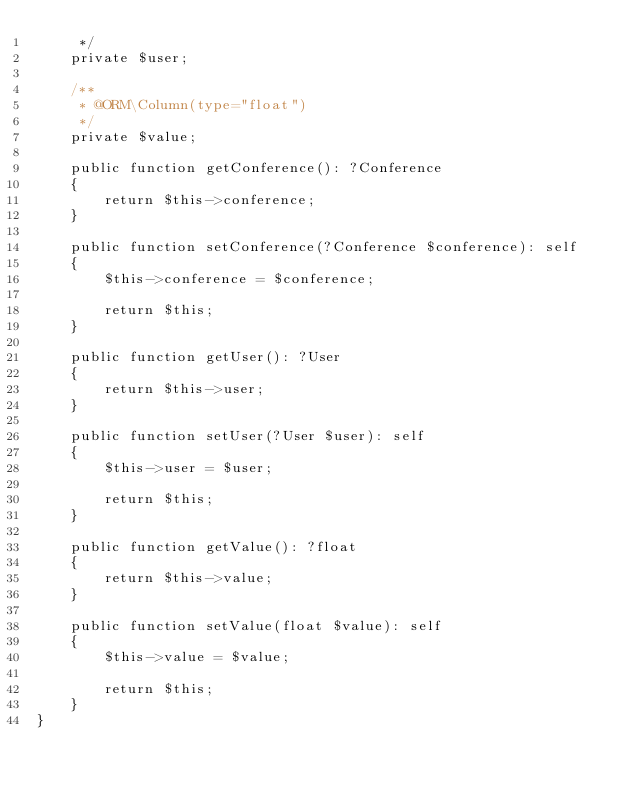<code> <loc_0><loc_0><loc_500><loc_500><_PHP_>     */
    private $user;

    /**
     * @ORM\Column(type="float")
     */
    private $value;

    public function getConference(): ?Conference
    {
        return $this->conference;
    }

    public function setConference(?Conference $conference): self
    {
        $this->conference = $conference;

        return $this;
    }

    public function getUser(): ?User
    {
        return $this->user;
    }

    public function setUser(?User $user): self
    {
        $this->user = $user;

        return $this;
    }

    public function getValue(): ?float
    {
        return $this->value;
    }

    public function setValue(float $value): self
    {
        $this->value = $value;

        return $this;
    }
}
</code> 